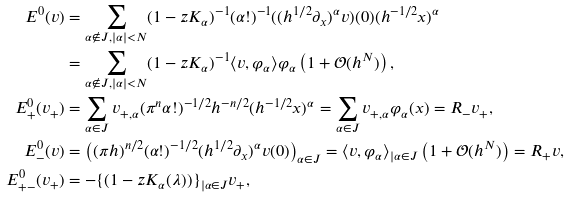<formula> <loc_0><loc_0><loc_500><loc_500>E ^ { 0 } ( v ) & = \sum _ { \alpha \not \in J , | \alpha | < N } ( 1 - z K _ { \alpha } ) ^ { - 1 } ( \alpha ! ) ^ { - 1 } ( ( h ^ { 1 / 2 } \partial _ { x } ) ^ { \alpha } v ) ( 0 ) ( h ^ { - 1 / 2 } x ) ^ { \alpha } \\ & = \sum _ { \alpha \not \in J , | \alpha | < N } ( 1 - z K _ { \alpha } ) ^ { - 1 } \langle v , \varphi _ { \alpha } \rangle \varphi _ { \alpha } \left ( 1 + { \mathcal { O } } ( h ^ { N } ) \right ) , \\ E _ { + } ^ { 0 } ( v _ { + } ) & = \sum _ { \alpha \in J } v _ { + , \alpha } ( \pi ^ { n } \alpha ! ) ^ { - 1 / 2 } h ^ { - n / 2 } ( h ^ { - 1 / 2 } x ) ^ { \alpha } = \sum _ { \alpha \in J } v _ { + , \alpha } \varphi _ { \alpha } ( x ) = R _ { - } v _ { + } , \\ E _ { - } ^ { 0 } ( v ) & = \left ( ( \pi h ) ^ { n / 2 } ( \alpha ! ) ^ { - 1 / 2 } ( h ^ { 1 / 2 } \partial _ { x } ) ^ { \alpha } v ( 0 ) \right ) _ { \alpha \in J } = \langle v , \varphi _ { \alpha } \rangle _ { | \alpha \in J } \left ( 1 + { \mathcal { O } } ( h ^ { N } ) \right ) = R _ { + } v , \\ E _ { + - } ^ { 0 } ( v _ { + } ) & = - \{ ( 1 - z K _ { \alpha } ( \lambda ) ) \} _ { | \alpha \in J } v _ { + } ,</formula> 